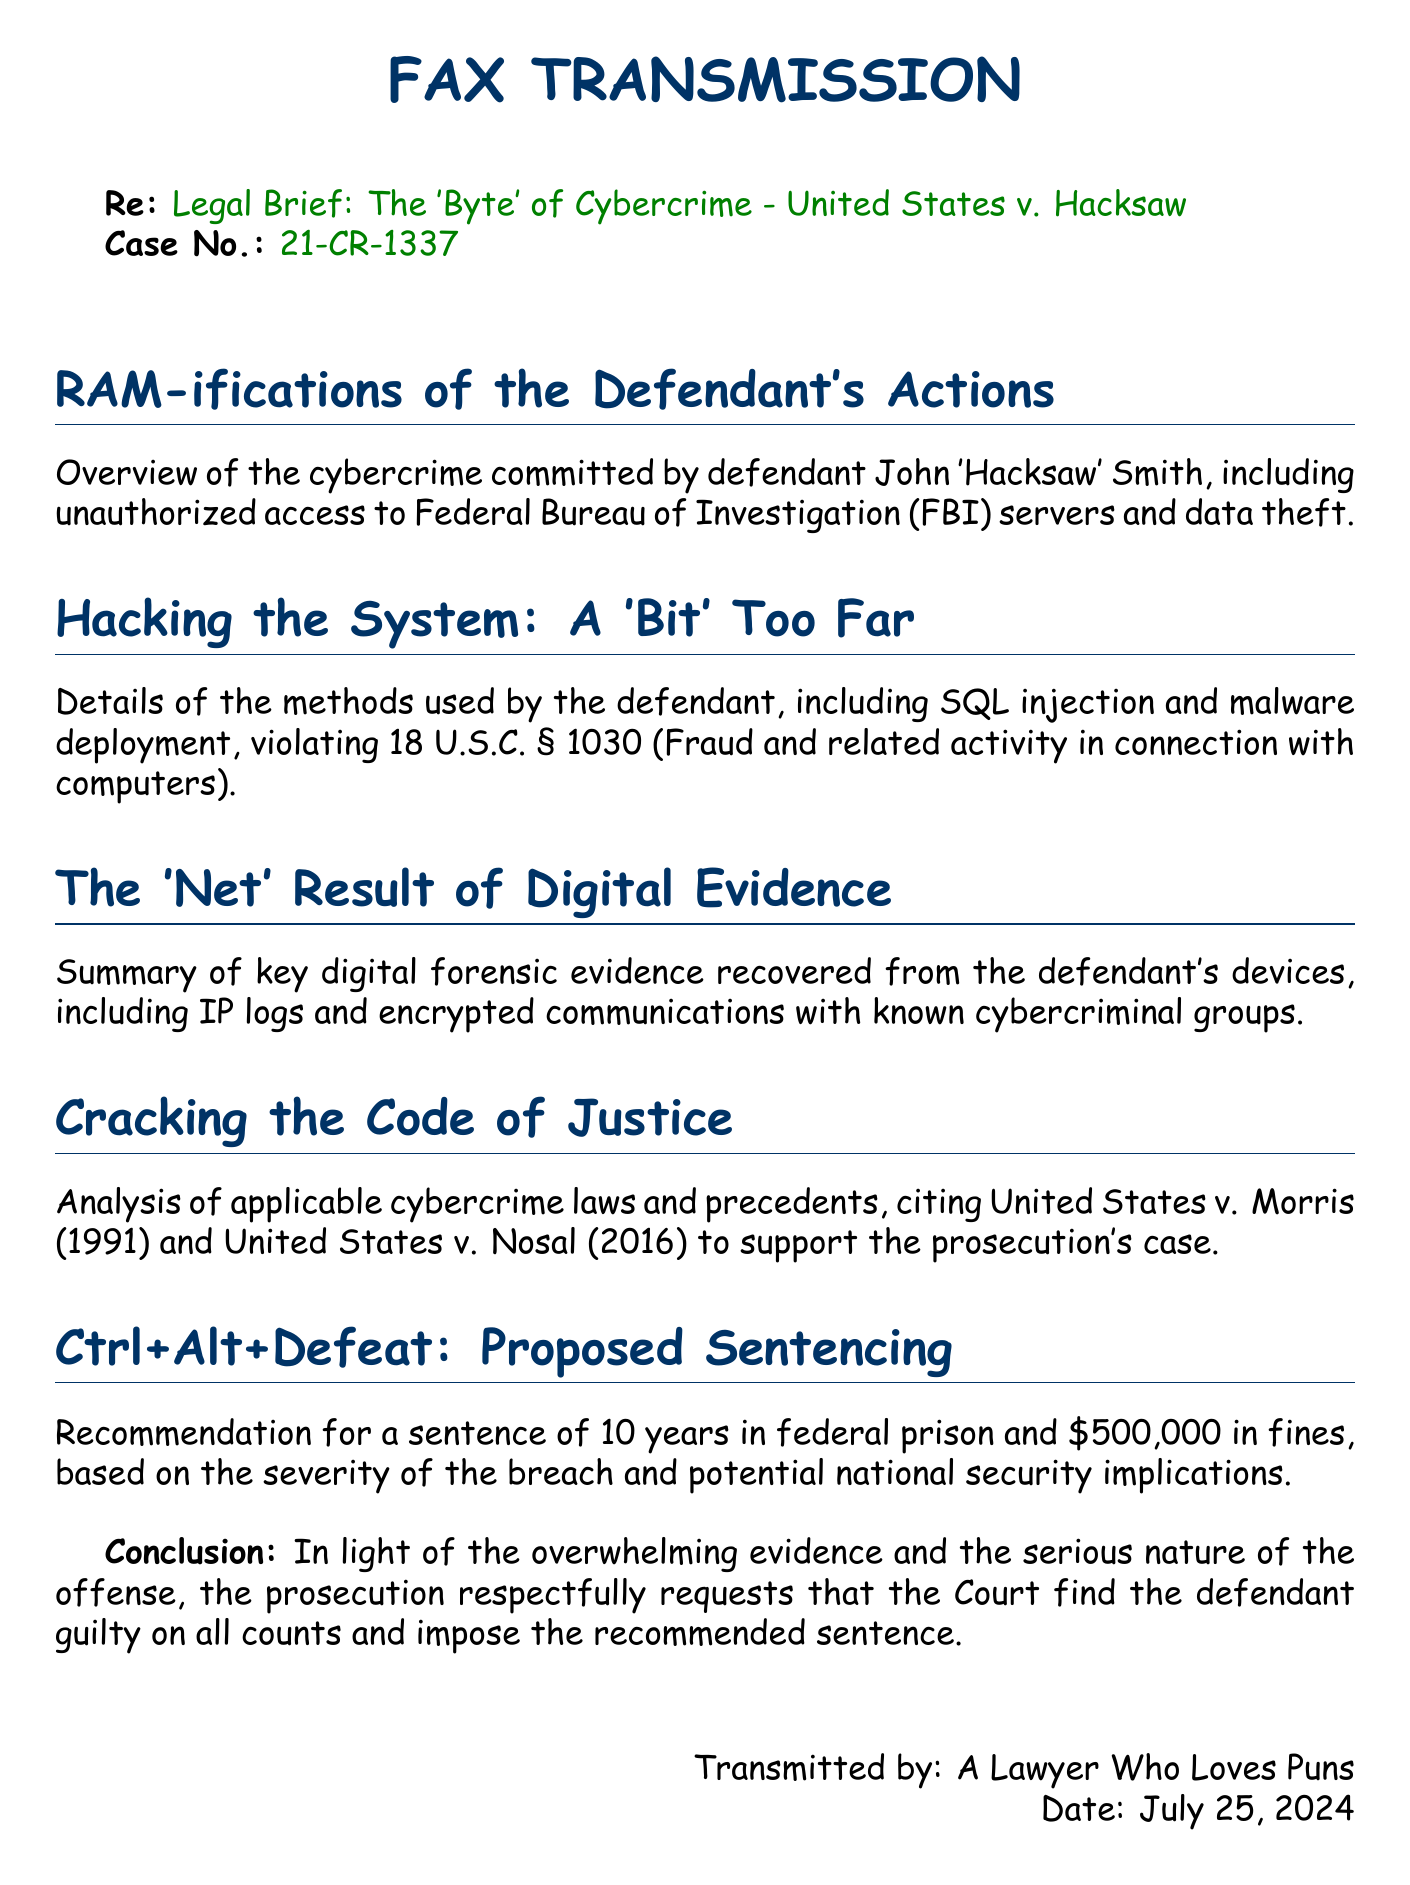What is the case number? The case number is presented in the fax as "21-CR-1337."
Answer: 21-CR-1337 Who is the defendant? The defendant's name is mentioned in the overview section as "John 'Hacksaw' Smith."
Answer: John 'Hacksaw' Smith What laws are being violated by the defendant? The document states the violation pertains to "18 U.S.C. § 1030."
Answer: 18 U.S.C. § 1030 What is the proposed sentence? The proposed sentence is outlined near the end of the fax and includes "10 years in federal prison."
Answer: 10 years What is the recommended fine? The recommended fine is listed as "$500,000" based on the severity of the breach.
Answer: $500,000 What type of evidence is summarized in the document? The text refers to "digital forensic evidence" recovered from the defendant's devices.
Answer: digital forensic evidence What is the main focus of the brief? The overall focus of the brief is on the "Byte of Cybercrime" case.
Answer: Byte of Cybercrime Which case is cited as a precedent? The brief cites "United States v. Morris (1991)" and "United States v. Nosal (2016)" as precedents.
Answer: United States v. Morris (1991) and United States v. Nosal (2016) 